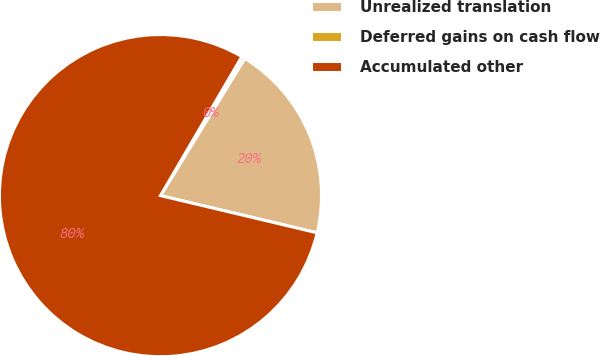Convert chart to OTSL. <chart><loc_0><loc_0><loc_500><loc_500><pie_chart><fcel>Unrealized translation<fcel>Deferred gains on cash flow<fcel>Accumulated other<nl><fcel>19.94%<fcel>0.34%<fcel>79.72%<nl></chart> 